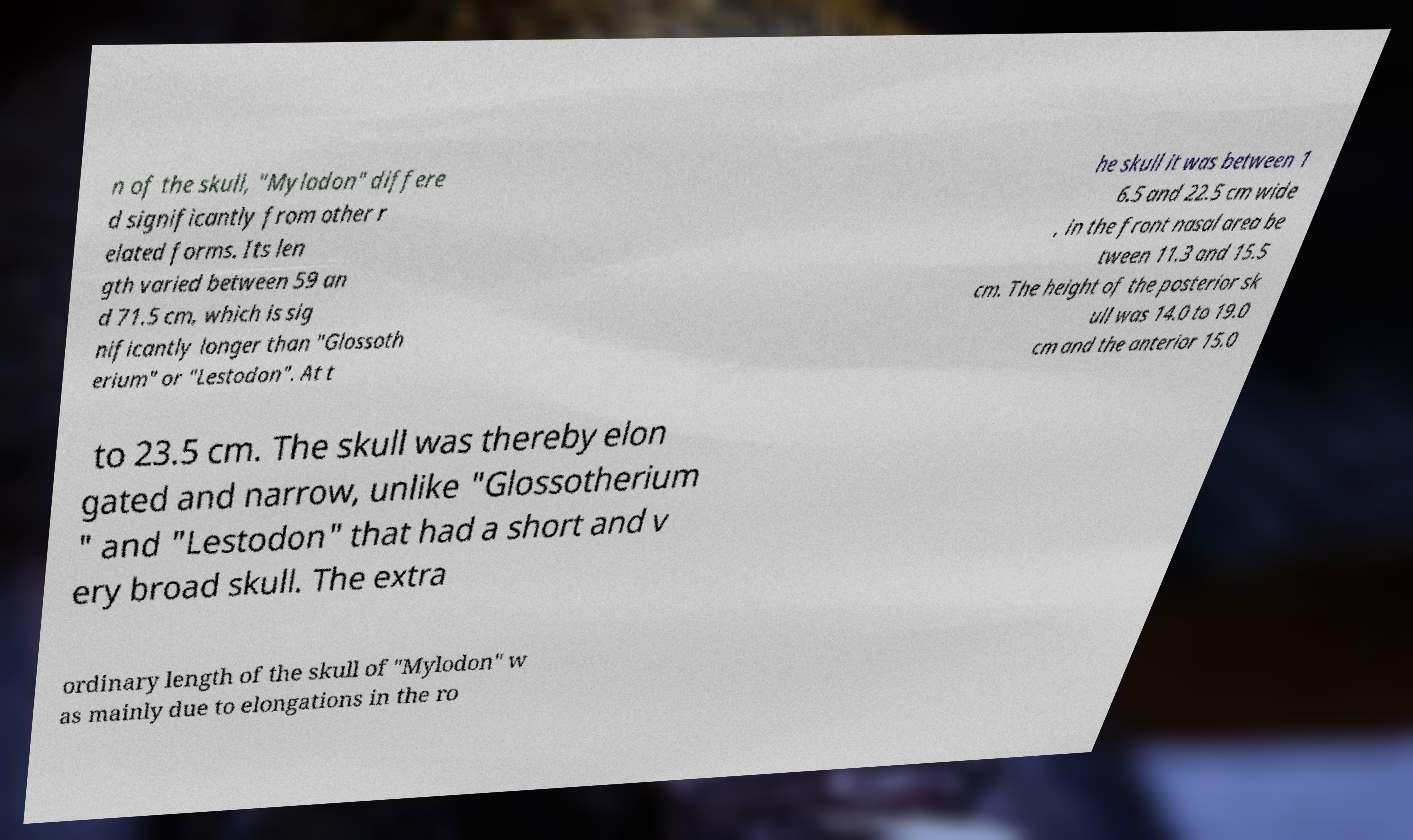Could you assist in decoding the text presented in this image and type it out clearly? n of the skull, "Mylodon" differe d significantly from other r elated forms. Its len gth varied between 59 an d 71.5 cm, which is sig nificantly longer than "Glossoth erium" or "Lestodon". At t he skull it was between 1 6.5 and 22.5 cm wide , in the front nasal area be tween 11.3 and 15.5 cm. The height of the posterior sk ull was 14.0 to 19.0 cm and the anterior 15.0 to 23.5 cm. The skull was thereby elon gated and narrow, unlike "Glossotherium " and "Lestodon" that had a short and v ery broad skull. The extra ordinary length of the skull of "Mylodon" w as mainly due to elongations in the ro 